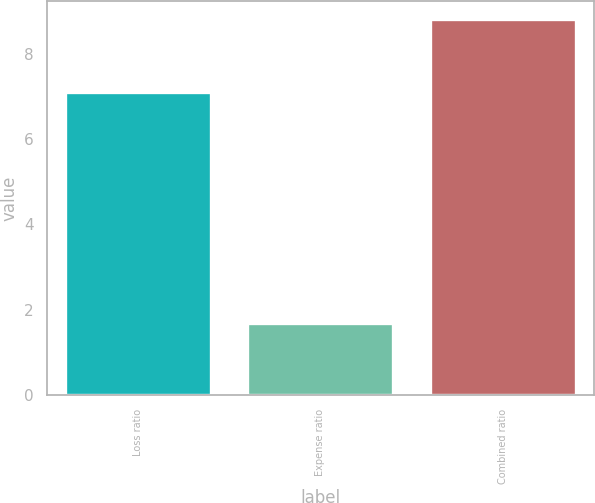Convert chart to OTSL. <chart><loc_0><loc_0><loc_500><loc_500><bar_chart><fcel>Loss ratio<fcel>Expense ratio<fcel>Combined ratio<nl><fcel>7.1<fcel>1.7<fcel>8.8<nl></chart> 